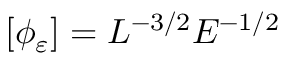<formula> <loc_0><loc_0><loc_500><loc_500>\left [ \phi _ { \varepsilon } \right ] = L ^ { - 3 / 2 } E ^ { - 1 / 2 }</formula> 